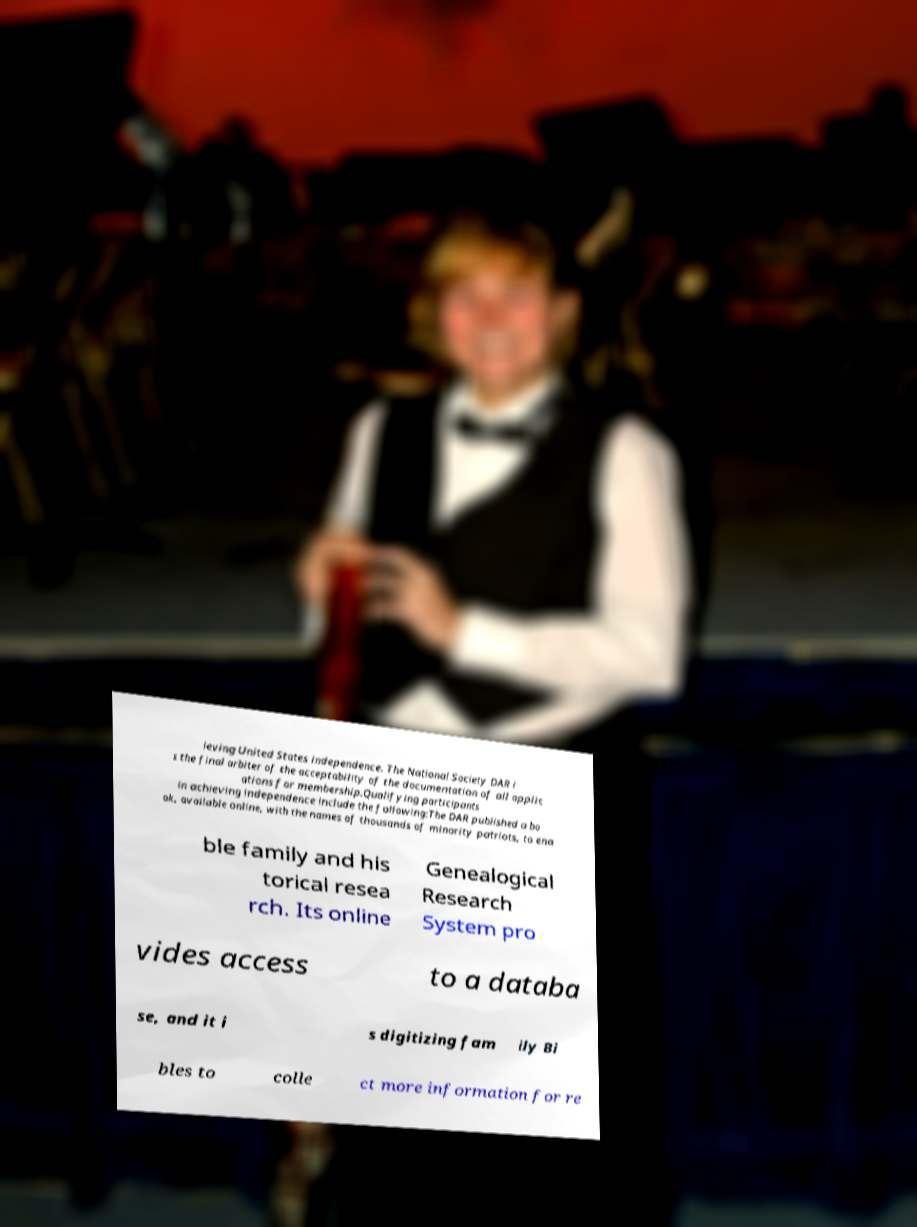Could you assist in decoding the text presented in this image and type it out clearly? ieving United States independence. The National Society DAR i s the final arbiter of the acceptability of the documentation of all applic ations for membership.Qualifying participants in achieving independence include the following:The DAR published a bo ok, available online, with the names of thousands of minority patriots, to ena ble family and his torical resea rch. Its online Genealogical Research System pro vides access to a databa se, and it i s digitizing fam ily Bi bles to colle ct more information for re 